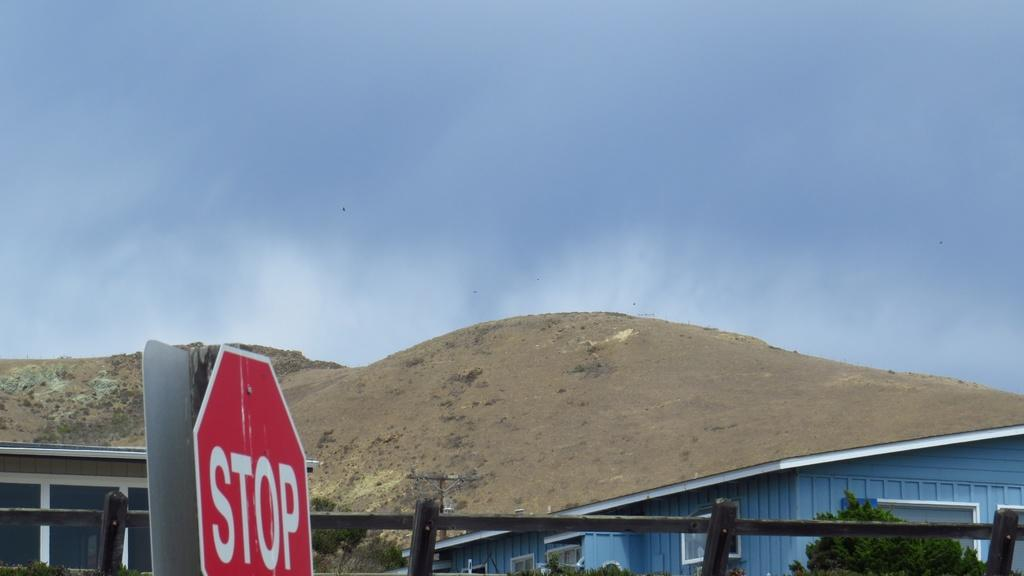<image>
Give a short and clear explanation of the subsequent image. A red Stop  sign on a post in front of a wood fence and a brown dirt hill. 